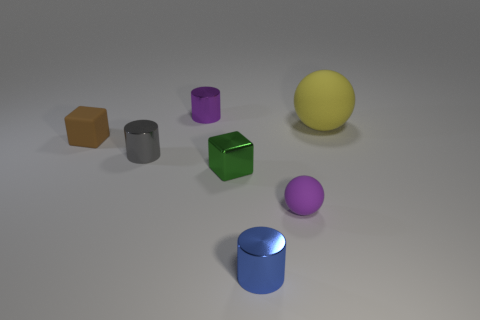Add 2 metallic cylinders. How many objects exist? 9 Subtract all blocks. How many objects are left? 5 Subtract all large red balls. Subtract all purple things. How many objects are left? 5 Add 3 tiny gray things. How many tiny gray things are left? 4 Add 3 purple rubber spheres. How many purple rubber spheres exist? 4 Subtract 0 cyan cylinders. How many objects are left? 7 